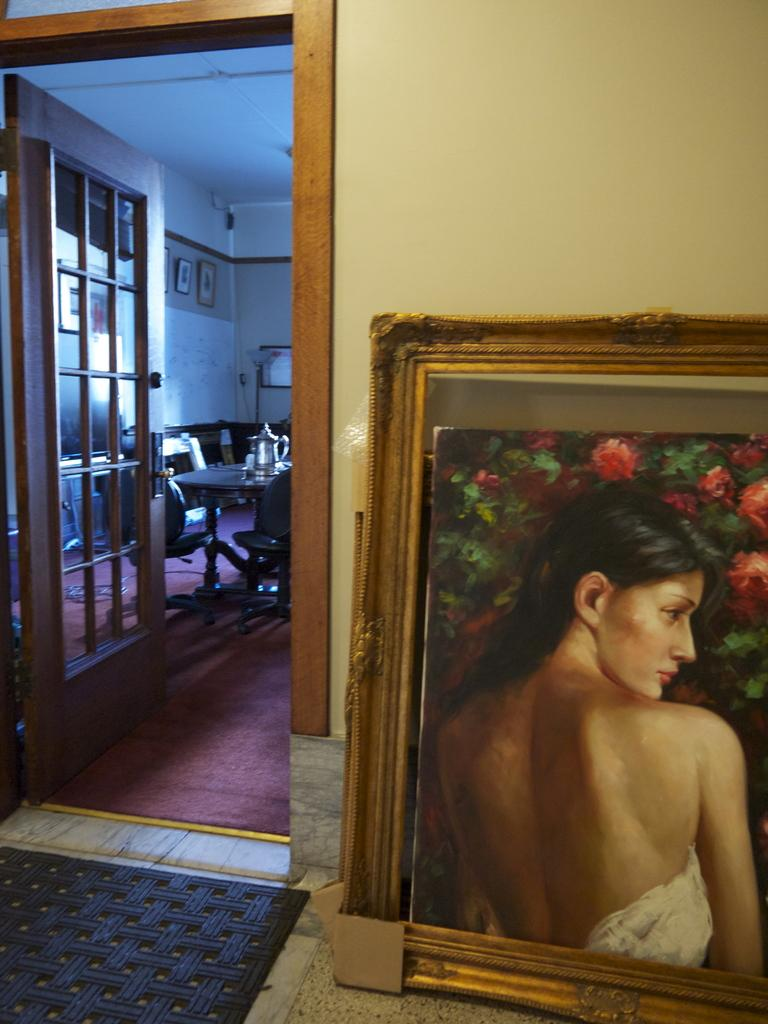What object can be seen in the image that is typically used for displaying photos? There is a photo frame in the image. What type of structure is visible in the background of the image? There is a wall in the image. What architectural feature is present in the image that allows for entering or exiting a room? There is a door in the image. What piece of furniture is visible in the image that is commonly used for placing items? There is a table in the image. What can be found on the table in the image? There are objects on the table. Where is the plant located in the image? There is no plant present in the image. What type of nest can be seen in the image? There is no nest present in the image. 